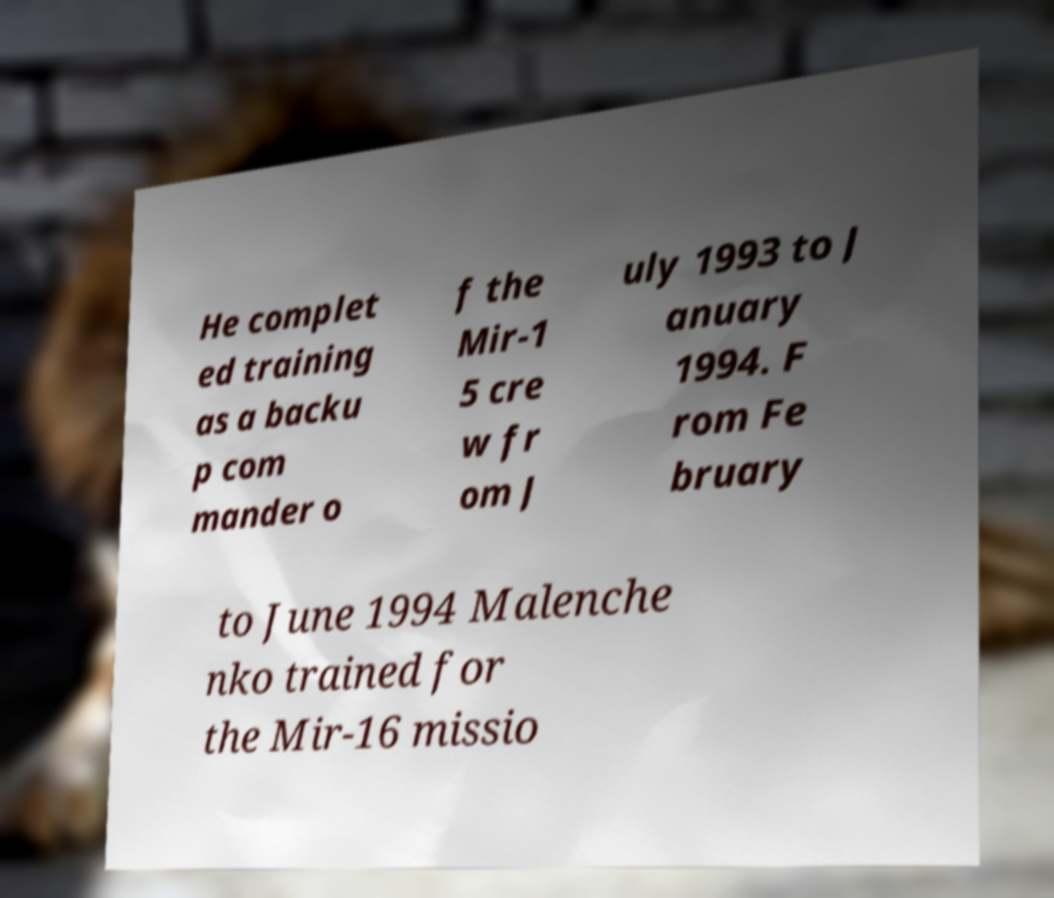I need the written content from this picture converted into text. Can you do that? He complet ed training as a backu p com mander o f the Mir-1 5 cre w fr om J uly 1993 to J anuary 1994. F rom Fe bruary to June 1994 Malenche nko trained for the Mir-16 missio 